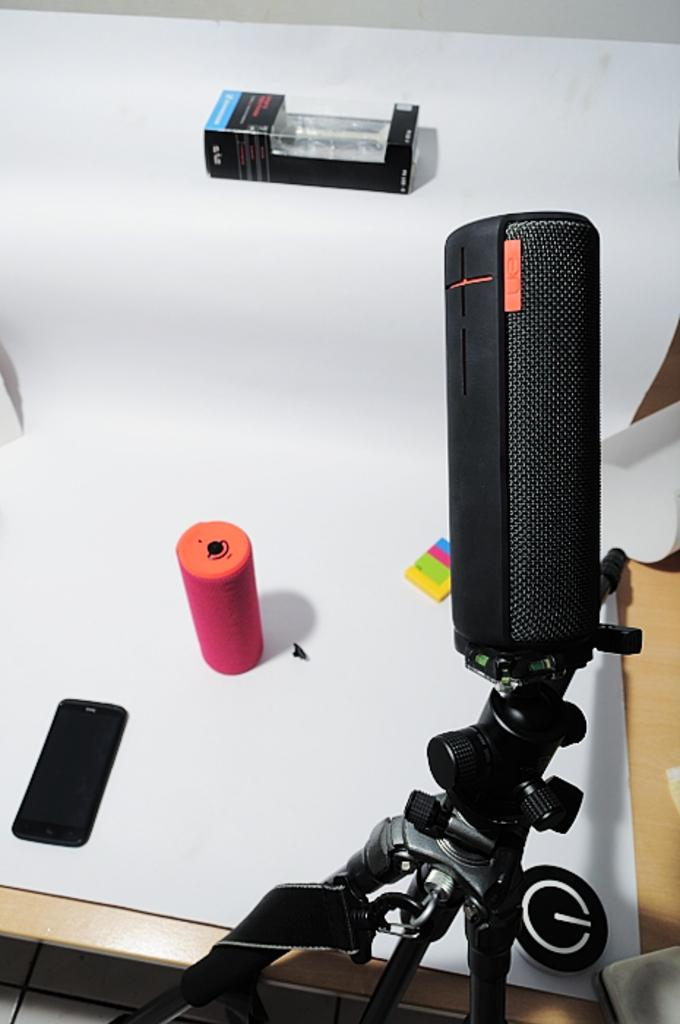What object is located on the right side of the image? There is a microphone on the right side of the image. What is on the table in the image? There is a mobile and a box on the table in the image. Can you describe any other objects on the table? There are other unspecified things on the table in the image. Is there a tray with a haircut being given on the table in the image? No, there is no tray or haircut being given on the table in the image. Can you see any worms crawling on the microphone in the image? No, there are no worms visible on the microphone or anywhere else in the image. 